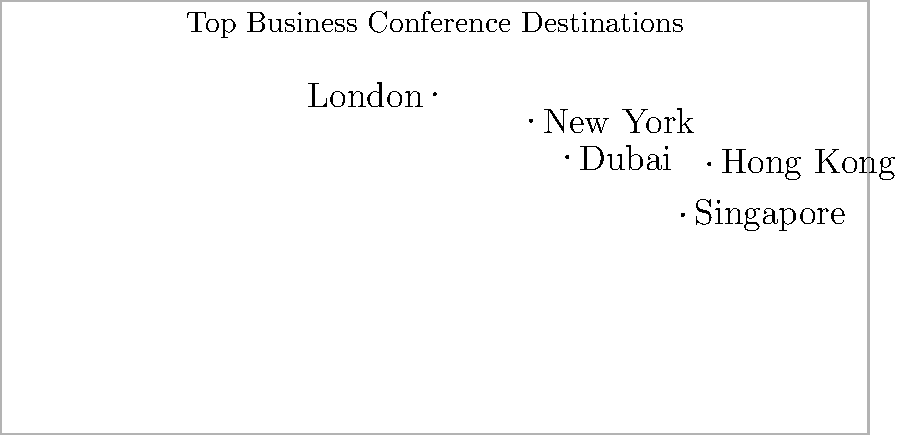Based on the world map showing top business conference destinations, which city appears to be the most centrally located for international attendees, considering global travel routes? To determine the most centrally located city for international attendees, we need to consider the following steps:

1. Identify the cities shown on the map:
   - New York
   - London
   - Dubai
   - Singapore
   - Hong Kong

2. Analyze their geographical positions:
   - New York: Western hemisphere, North America
   - London: Western Europe
   - Dubai: Middle East
   - Singapore: Southeast Asia
   - Hong Kong: East Asia

3. Consider global travel routes:
   - East-West routes between Americas, Europe, and Asia
   - North-South routes connecting various continents

4. Evaluate each city's position:
   - New York and Hong Kong are on opposite sides of the map
   - London is relatively far west
   - Singapore is far south
   - Dubai is positioned between Europe and Asia

5. Assess Dubai's central location:
   - Situated between East and West
   - Connects Europe, Asia, and Africa
   - Relatively equidistant from other major business hubs

6. Consider Dubai's role in international business:
   - Major transit hub for global air travel
   - Connects Eastern and Western hemispheres

Based on these factors, Dubai appears to be the most centrally located city for international attendees, offering convenient access from various parts of the world.
Answer: Dubai 